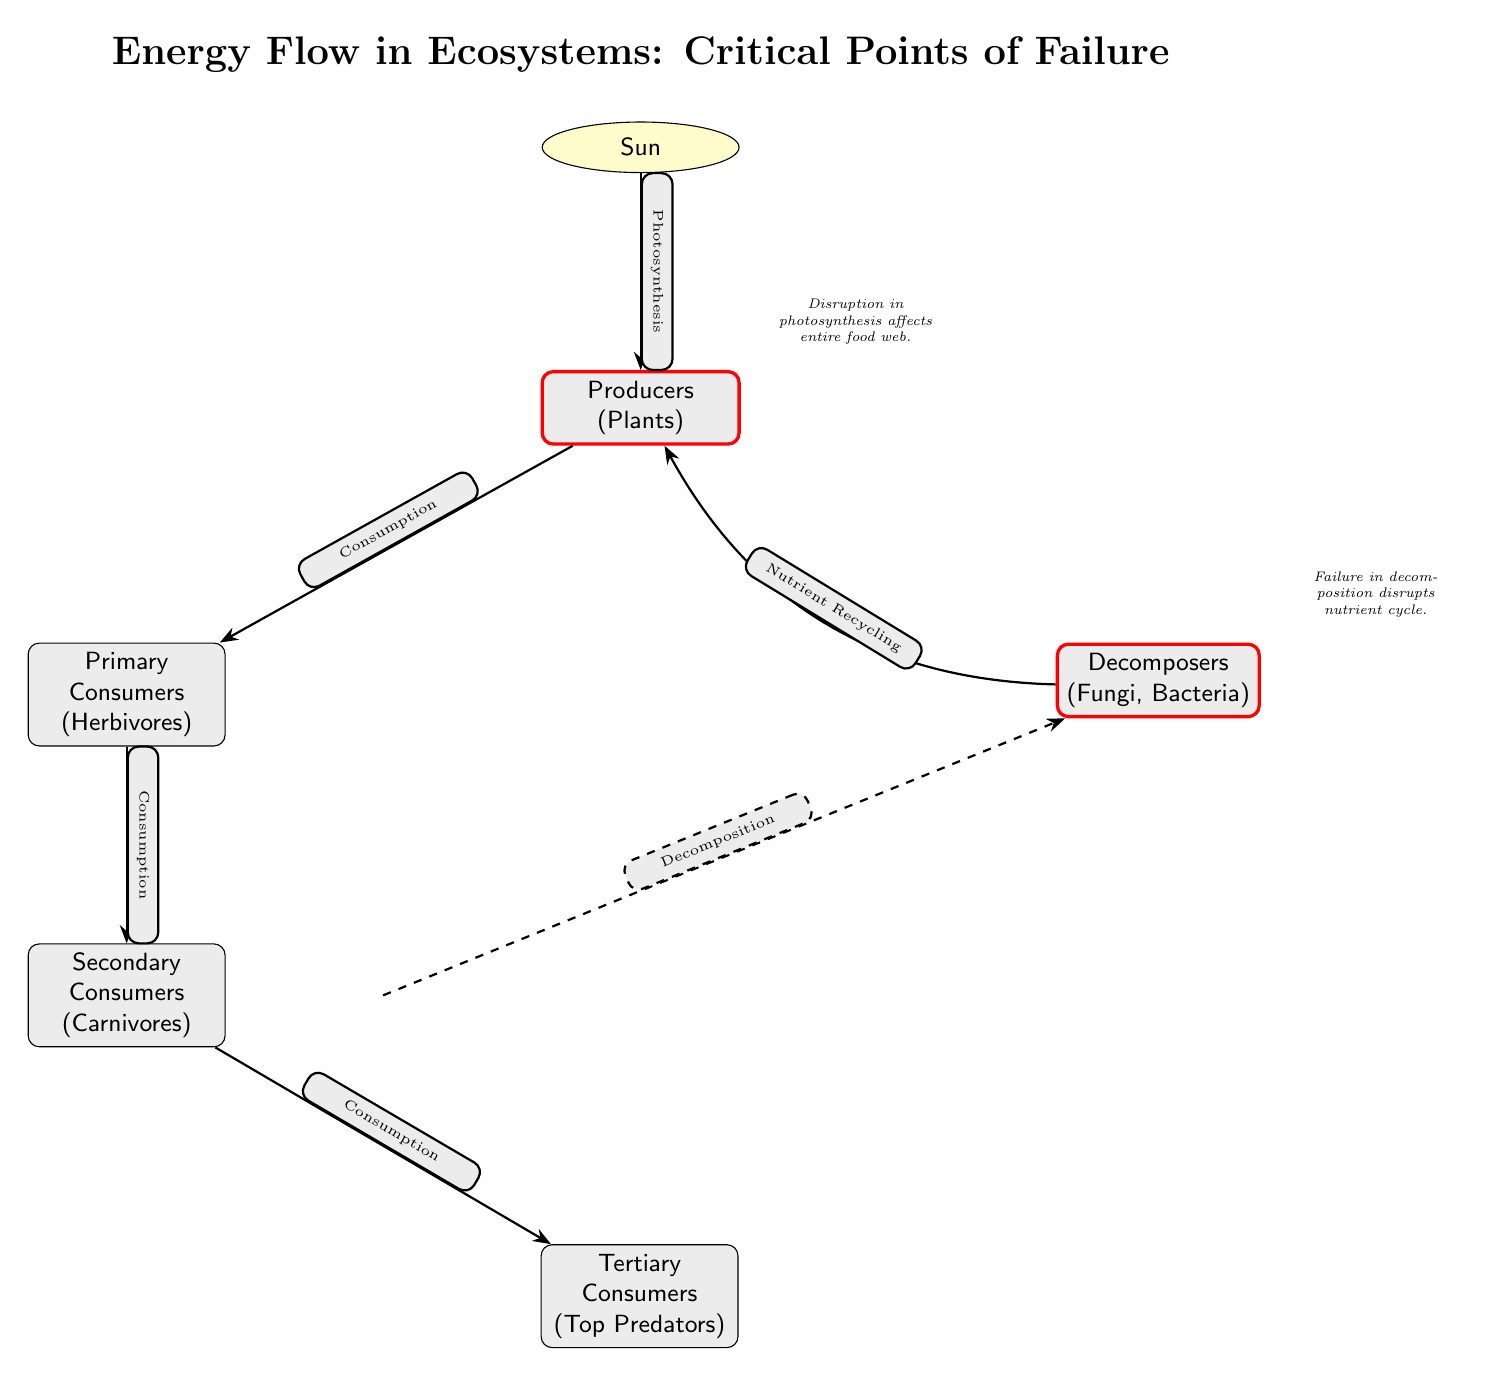What is the critical point of failure related to producers? The critical point of failure related to producers is the disruption in photosynthesis, which affects the entire food web by preventing energy capture from the sun.
Answer: Disruption in photosynthesis What do decomposers recycle back to producers? Decomposers recycle nutrients back to producers. This process is crucial for maintaining the nutrient cycle in the ecosystem.
Answer: Nutrients How many types of consumers are represented in the diagram? There are three types of consumers represented in the diagram: primary consumers (herbivores), secondary consumers (carnivores), and tertiary consumers (top predators). This counts to three distinct types.
Answer: Three What is the relationship between primary consumers and secondary consumers? The relationship between primary consumers and secondary consumers is one of consumption, where primary consumers are eaten by secondary consumers in the energy flow.
Answer: Consumption What would happen if there was a failure in decomposition? If there was a failure in decomposition, it would disrupt the nutrient cycle, preventing the recycling of essential nutrients back to producers and impacting the whole ecosystem's energy flow.
Answer: Disruption of nutrient cycle What process connects producers and primary consumers? The process that connects producers and primary consumers is called consumption, where primary consumers eat producers.
Answer: Consumption How does energy from the sun reach tertiary consumers? Energy from the sun reaches tertiary consumers through a series of consumption events: first by producers (plants) capturing sunlight, then passed through primary and secondary consumers to the tertiary consumers.
Answer: Through consumption What do you call the diagram's main focus? The diagram's main focus is on energy flow in ecosystems and the identification of critical points of failure that can disrupt this flow.
Answer: Energy Flow in Ecosystems Which organism type is least represented in terms of number in this ecosystem diagram? The organism type least represented in terms of number in this ecosystem diagram is tertiary consumers, as they are typically fewer in number compared to producers and primary consumers.
Answer: Tertiary Consumers 